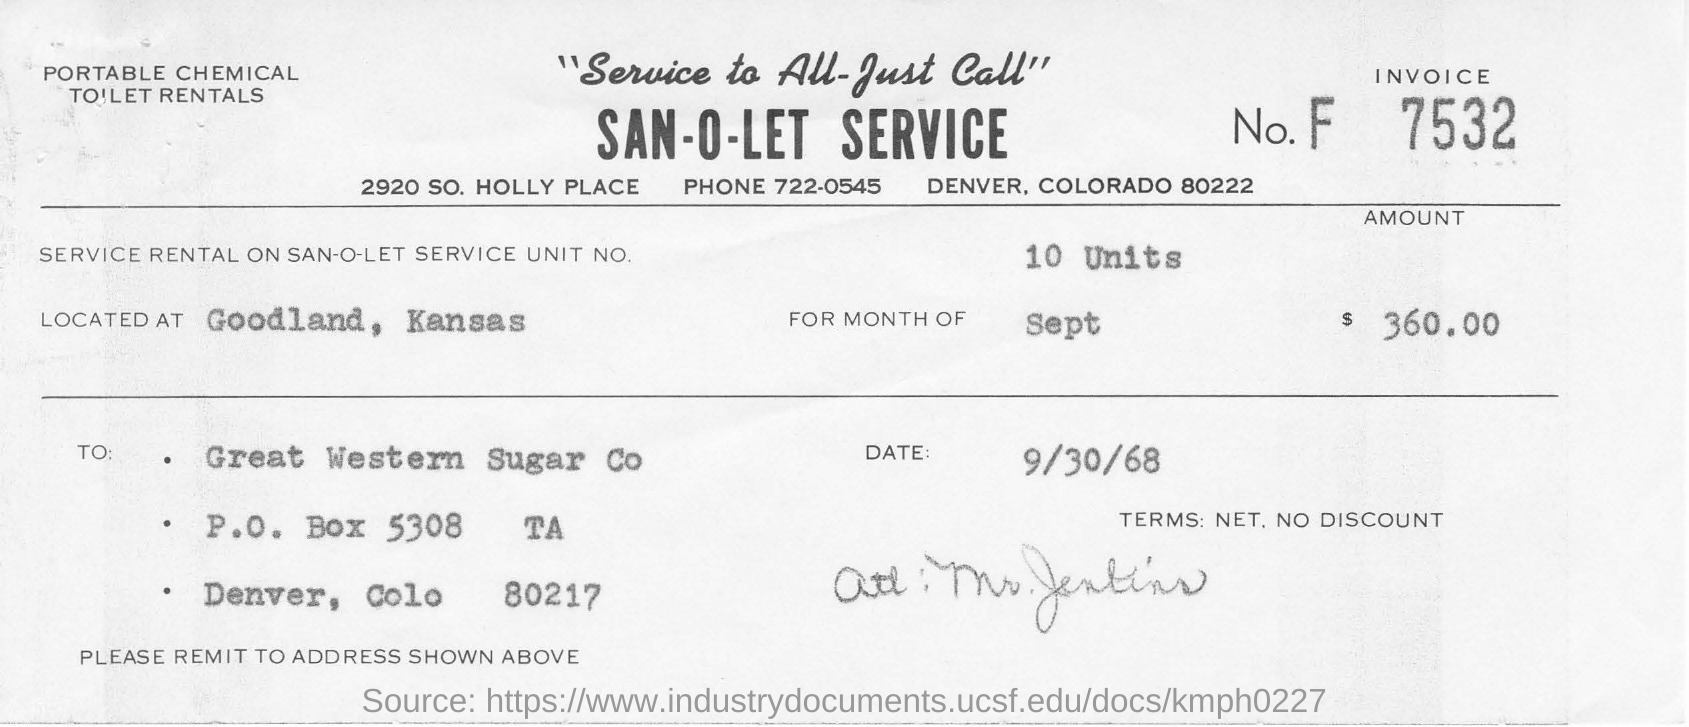Point out several critical features in this image. The invoice number listed in the document is 7532. The phone number mentioned in this document is 722-0545. The date mentioned in this document is September 30, 1968. What is the service rental cost for 10 units of the San-o-let service? 